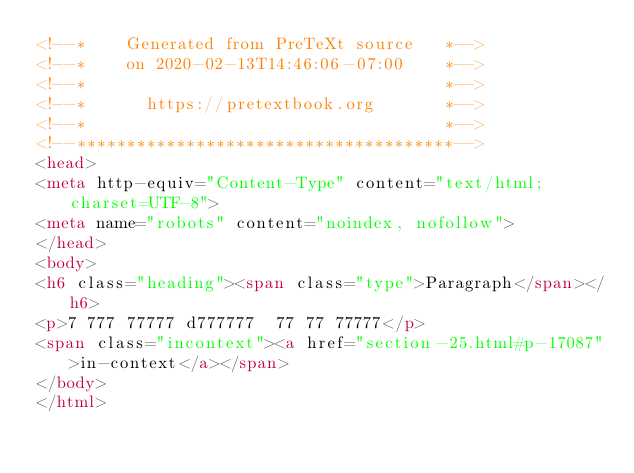Convert code to text. <code><loc_0><loc_0><loc_500><loc_500><_HTML_><!--*    Generated from PreTeXt source   *-->
<!--*    on 2020-02-13T14:46:06-07:00    *-->
<!--*                                    *-->
<!--*      https://pretextbook.org       *-->
<!--*                                    *-->
<!--**************************************-->
<head>
<meta http-equiv="Content-Type" content="text/html; charset=UTF-8">
<meta name="robots" content="noindex, nofollow">
</head>
<body>
<h6 class="heading"><span class="type">Paragraph</span></h6>
<p>7 777 77777 d777777  77 77 77777</p>
<span class="incontext"><a href="section-25.html#p-17087">in-context</a></span>
</body>
</html>
</code> 